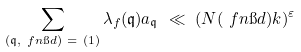<formula> <loc_0><loc_0><loc_500><loc_500>\sum _ { ( \mathfrak { q } , \ f n \i d ) \ = \ ( 1 ) } \lambda _ { f } ( \mathfrak { q } ) a _ { \mathfrak { q } } \ \ll \ ( N ( \ f n \i d ) k ) ^ { \varepsilon }</formula> 